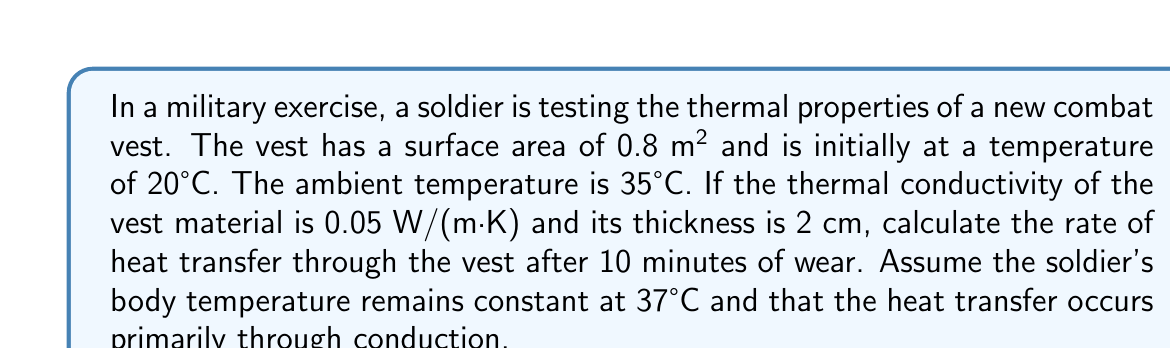Provide a solution to this math problem. Let's approach this problem step-by-step using the principles of heat transfer and statistical mechanics:

1) The heat transfer rate through conduction is given by Fourier's law:

   $$Q = -kA\frac{dT}{dx}$$

   Where:
   $Q$ = heat transfer rate (W)
   $k$ = thermal conductivity (W/(m·K))
   $A$ = surface area (m²)
   $\frac{dT}{dx}$ = temperature gradient (K/m)

2) We need to determine the temperature gradient. After 10 minutes of wear, we can assume a steady-state condition where the inner surface of the vest is at body temperature (37°C) and the outer surface is at ambient temperature (35°C).

3) The temperature difference is:
   $$\Delta T = 37°C - 35°C = 2K$$

4) The thickness of the vest is 0.02 m, so the temperature gradient is:
   $$\frac{dT}{dx} = \frac{2K}{0.02m} = 100 K/m$$

5) Now we can substitute all values into Fourier's law:
   $$Q = -(0.05 \frac{W}{m·K})(0.8m²)(100 \frac{K}{m})$$

6) Calculating:
   $$Q = -4W$$

The negative sign indicates that heat is flowing out of the body. In terms of magnitude, the heat transfer rate is 4W.
Answer: 4 W 